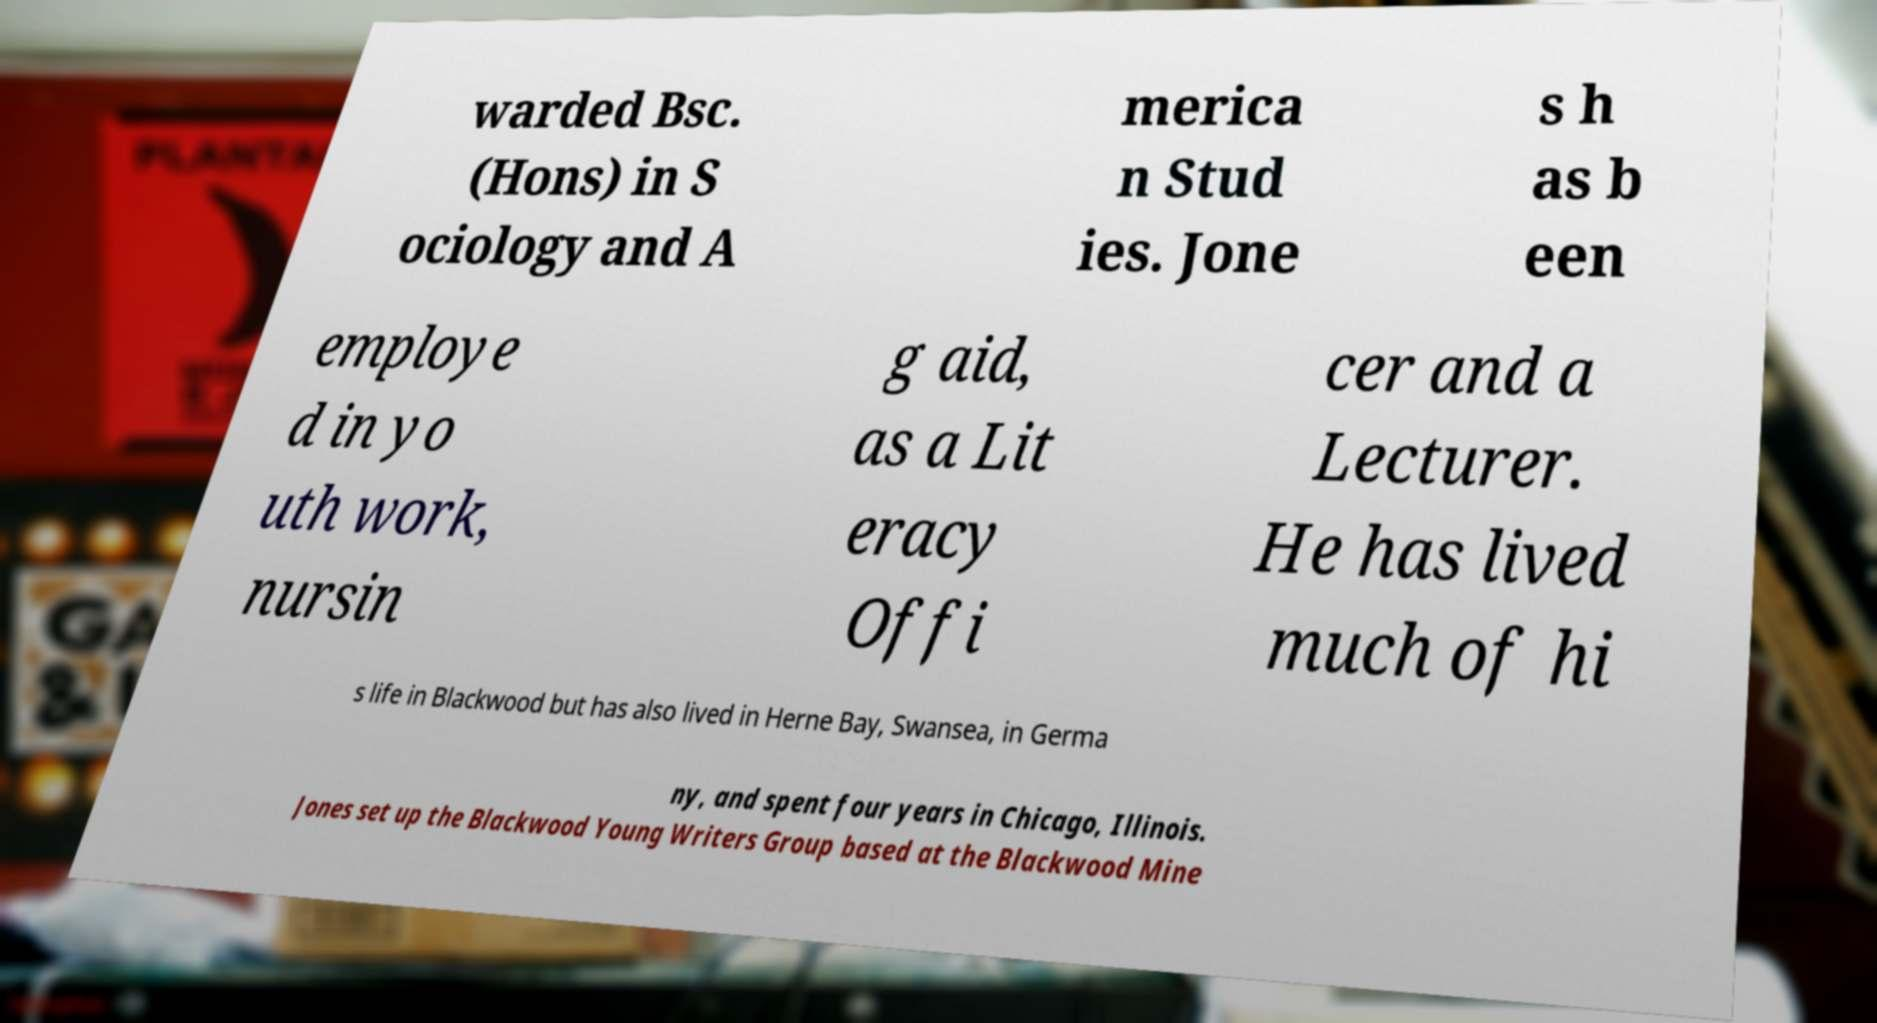There's text embedded in this image that I need extracted. Can you transcribe it verbatim? warded Bsc. (Hons) in S ociology and A merica n Stud ies. Jone s h as b een employe d in yo uth work, nursin g aid, as a Lit eracy Offi cer and a Lecturer. He has lived much of hi s life in Blackwood but has also lived in Herne Bay, Swansea, in Germa ny, and spent four years in Chicago, Illinois. Jones set up the Blackwood Young Writers Group based at the Blackwood Mine 